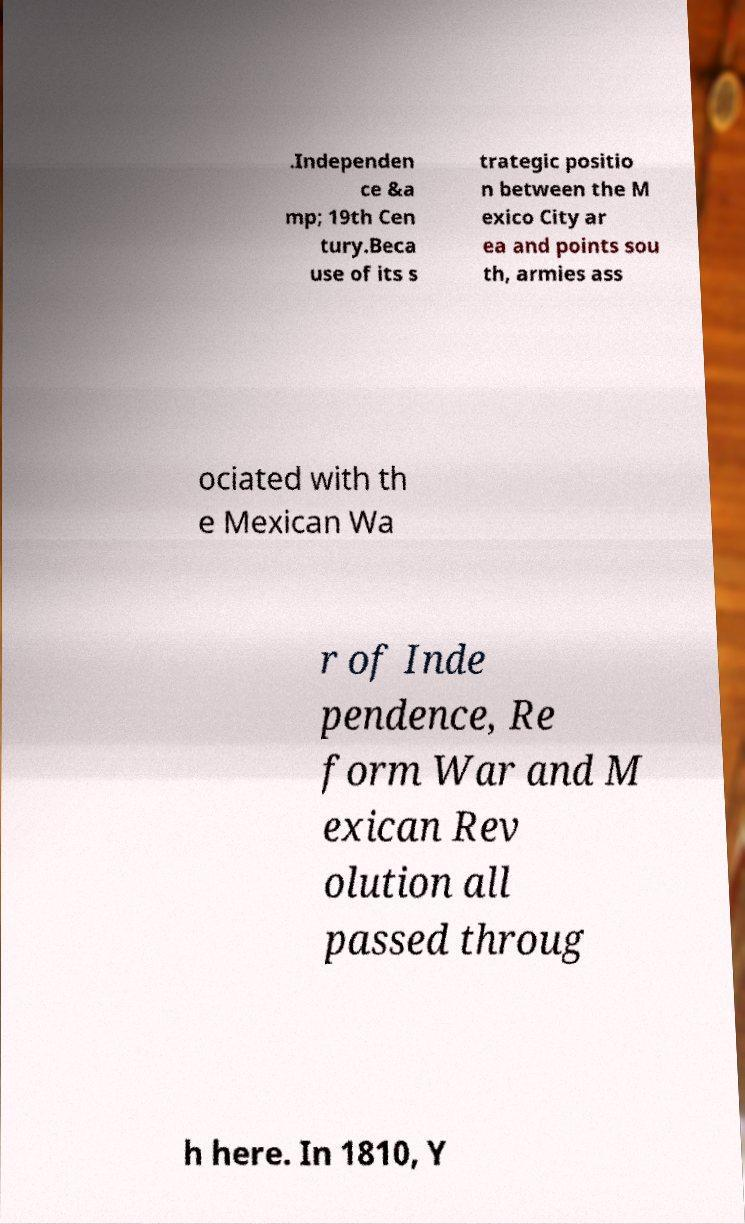Could you assist in decoding the text presented in this image and type it out clearly? .Independen ce &a mp; 19th Cen tury.Beca use of its s trategic positio n between the M exico City ar ea and points sou th, armies ass ociated with th e Mexican Wa r of Inde pendence, Re form War and M exican Rev olution all passed throug h here. In 1810, Y 